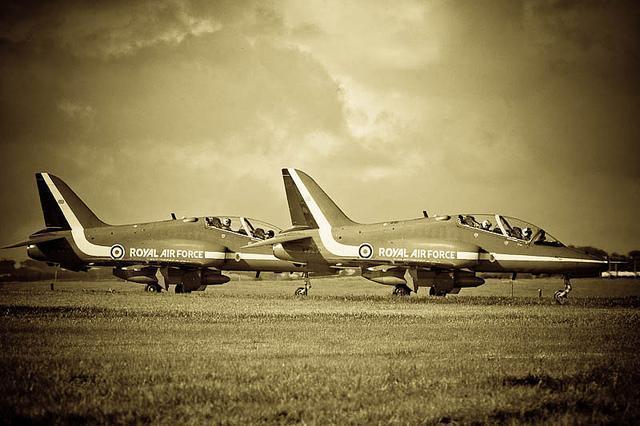How many planes are here?
Give a very brief answer. 2. How many airplanes can you see?
Give a very brief answer. 2. 